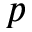Convert formula to latex. <formula><loc_0><loc_0><loc_500><loc_500>p</formula> 